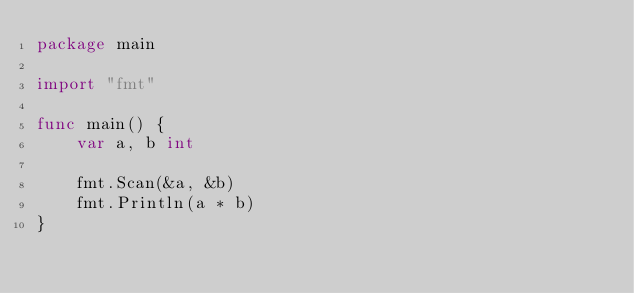<code> <loc_0><loc_0><loc_500><loc_500><_Go_>package main

import "fmt"

func main() {
	var a, b int

	fmt.Scan(&a, &b)
	fmt.Println(a * b)
}</code> 